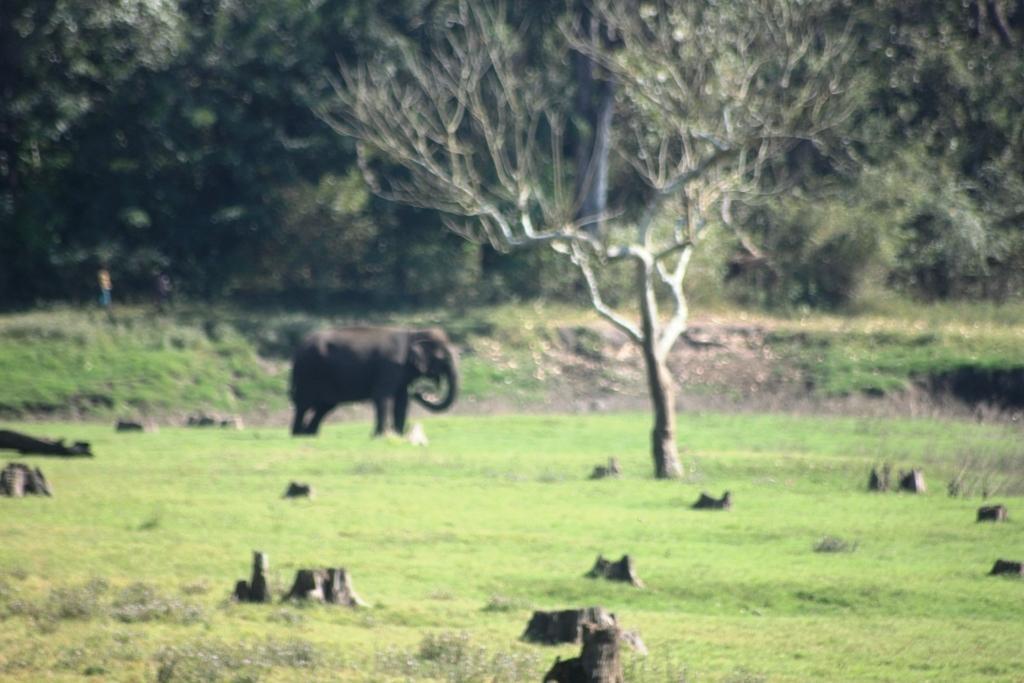Can you describe this image briefly? In this image we can see grassy land. In the background, we can see an elephant and trees. 